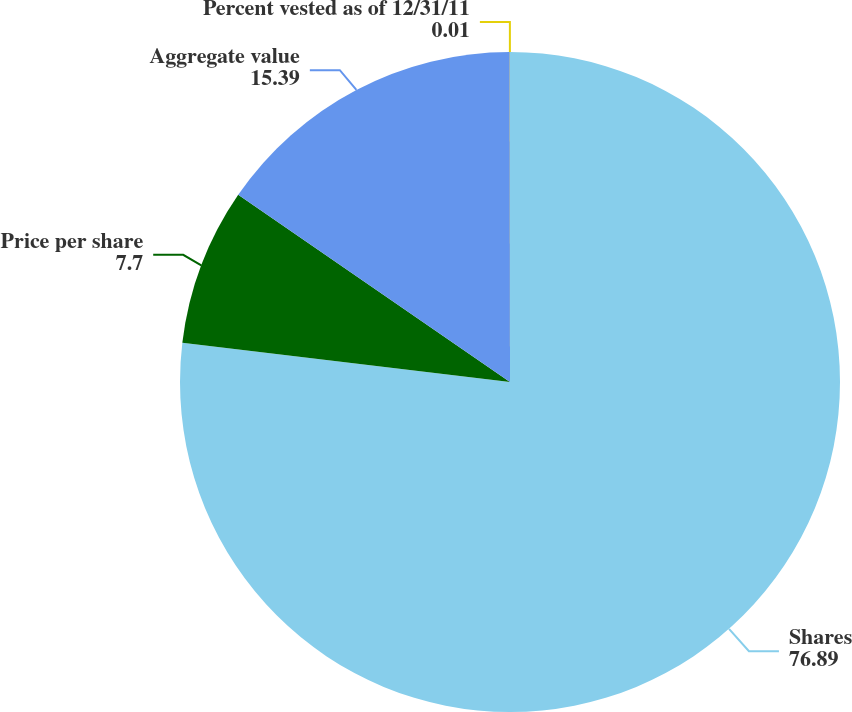Convert chart to OTSL. <chart><loc_0><loc_0><loc_500><loc_500><pie_chart><fcel>Shares<fcel>Price per share<fcel>Aggregate value<fcel>Percent vested as of 12/31/11<nl><fcel>76.89%<fcel>7.7%<fcel>15.39%<fcel>0.01%<nl></chart> 